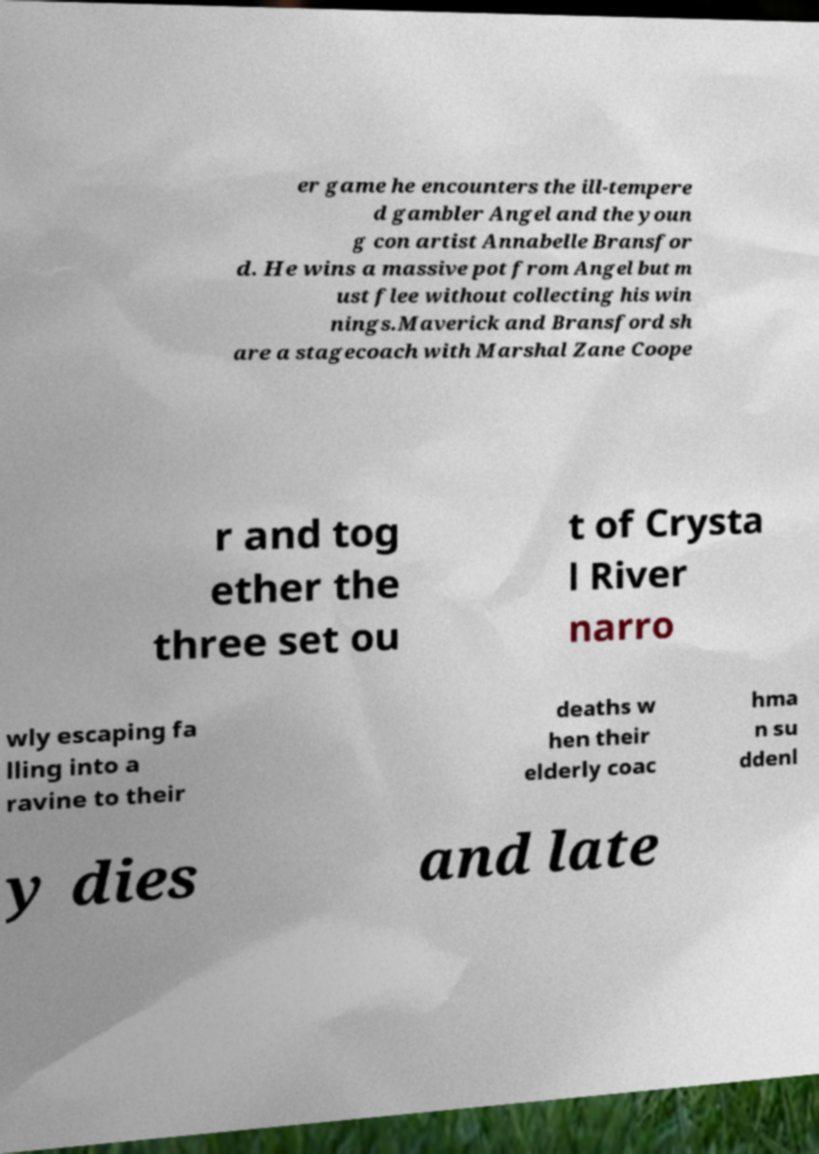I need the written content from this picture converted into text. Can you do that? er game he encounters the ill-tempere d gambler Angel and the youn g con artist Annabelle Bransfor d. He wins a massive pot from Angel but m ust flee without collecting his win nings.Maverick and Bransford sh are a stagecoach with Marshal Zane Coope r and tog ether the three set ou t of Crysta l River narro wly escaping fa lling into a ravine to their deaths w hen their elderly coac hma n su ddenl y dies and late 